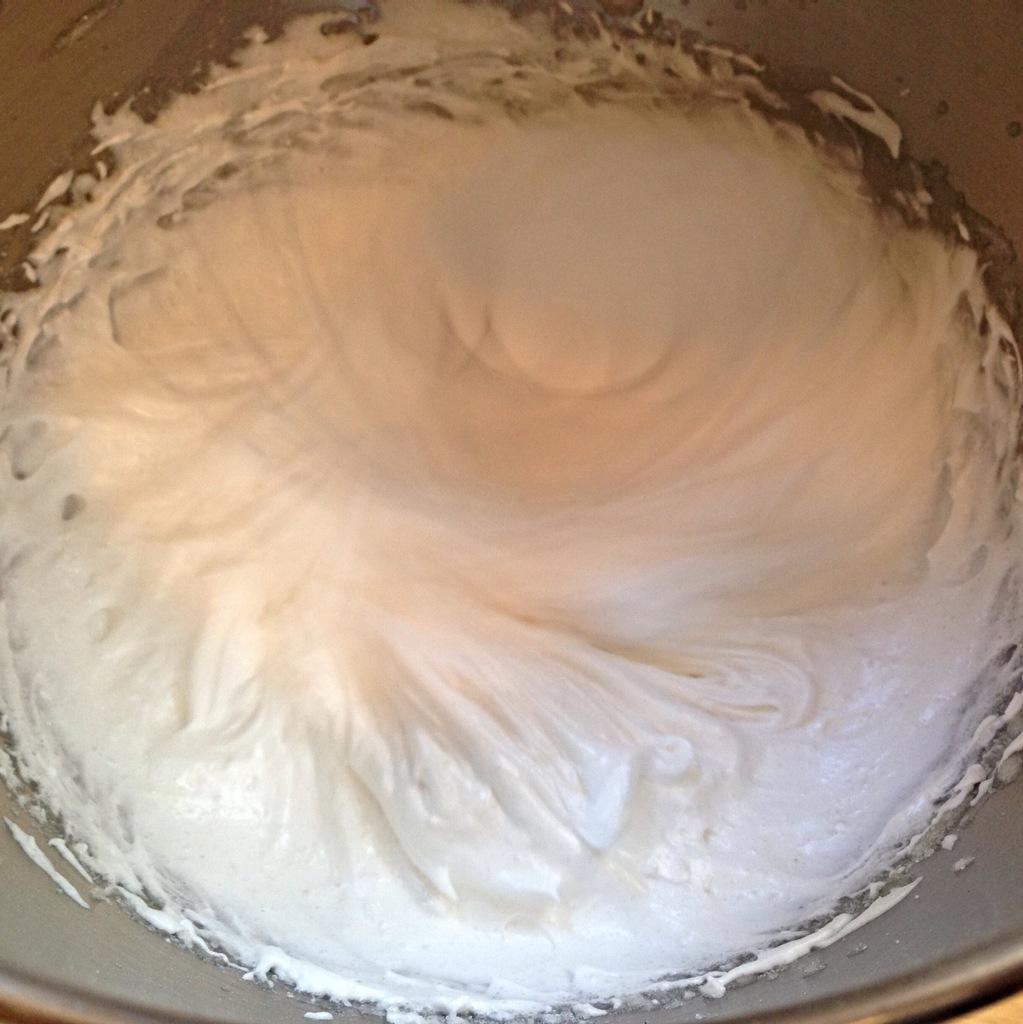What is the color of the cream in the vessel in the image? The cream in the vessel is white in color. What can be observed in the background of the image? The background of the image is gray in color. Is the cream in the vessel poisonous? There is no information in the image to suggest that the cream is poisonous. 